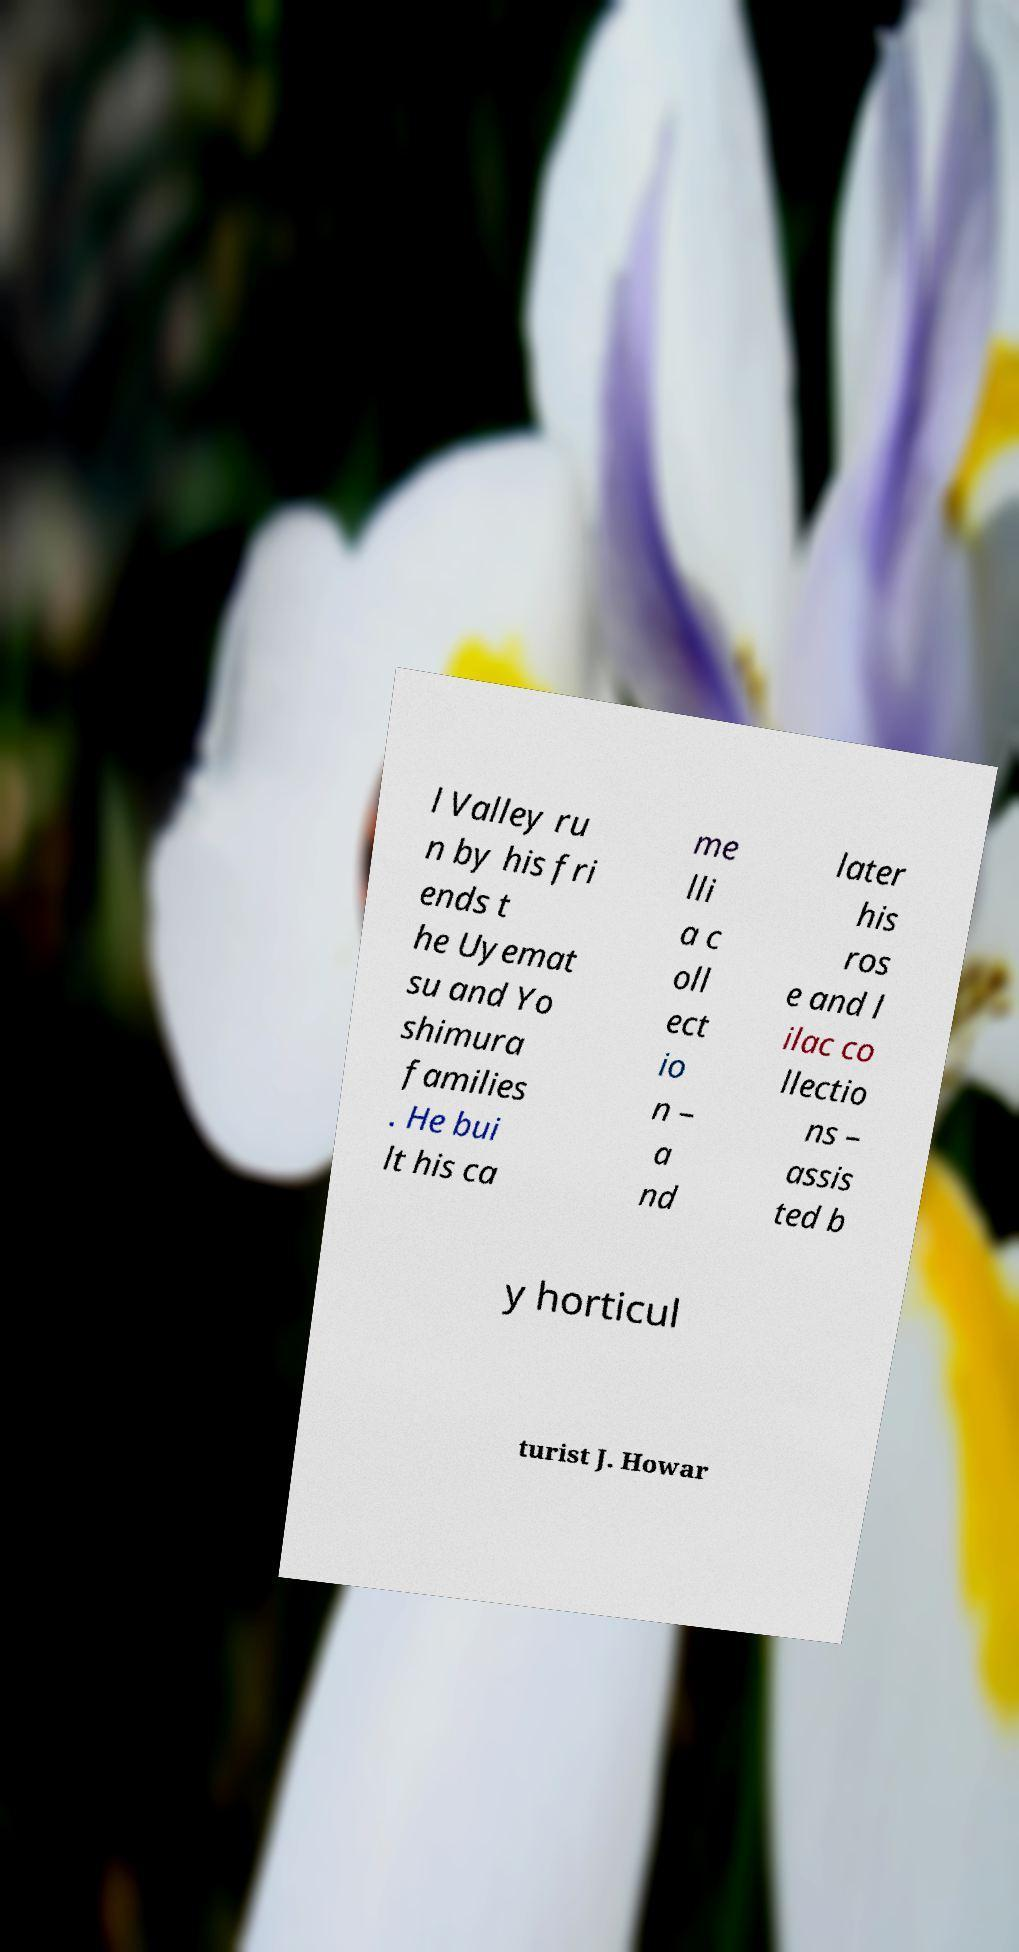Please identify and transcribe the text found in this image. l Valley ru n by his fri ends t he Uyemat su and Yo shimura families . He bui lt his ca me lli a c oll ect io n – a nd later his ros e and l ilac co llectio ns – assis ted b y horticul turist J. Howar 